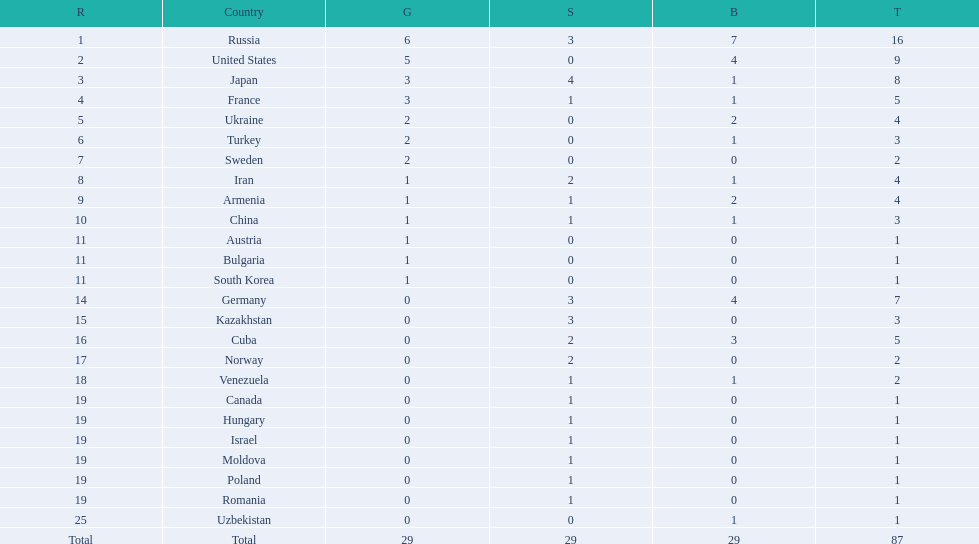What nations have one gold medal? Iran, Armenia, China, Austria, Bulgaria, South Korea. Of these, which nations have zero silver medals? Austria, Bulgaria, South Korea. Of these, which nations also have zero bronze medals? Austria. 